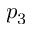Convert formula to latex. <formula><loc_0><loc_0><loc_500><loc_500>p _ { 3 }</formula> 